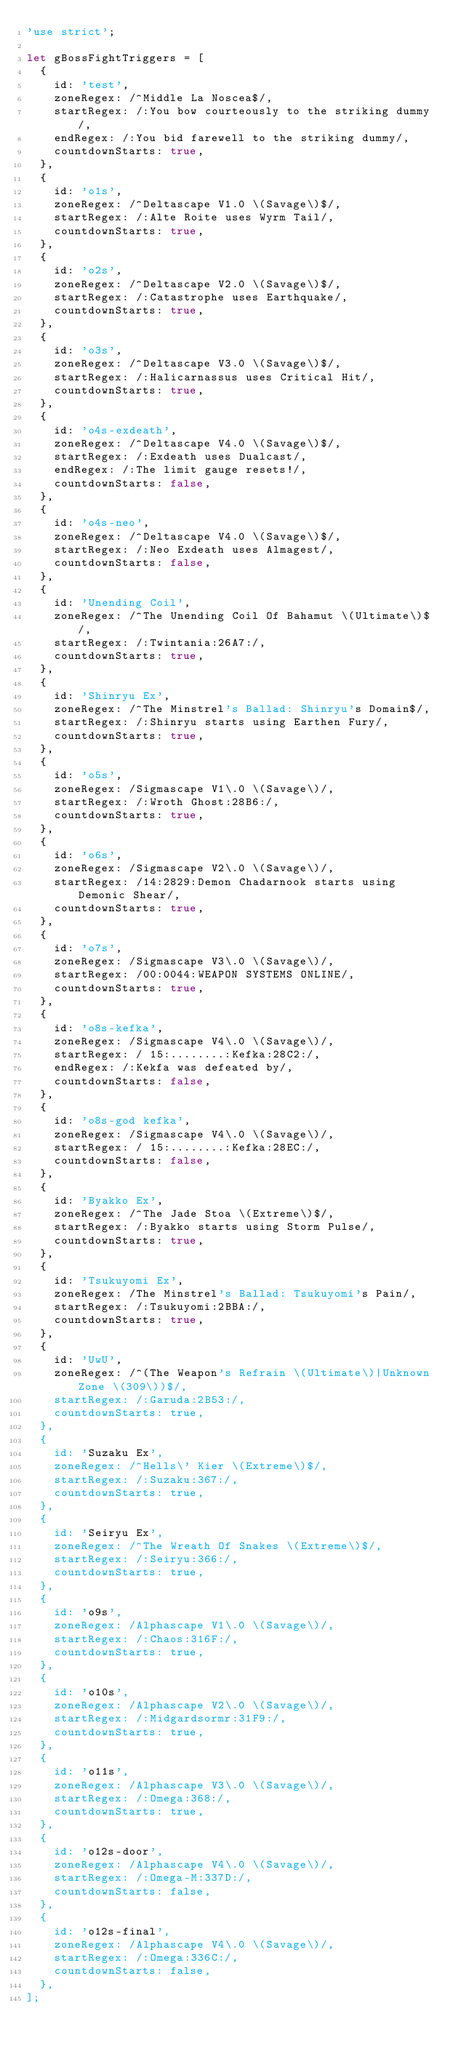<code> <loc_0><loc_0><loc_500><loc_500><_JavaScript_>'use strict';

let gBossFightTriggers = [
  {
    id: 'test',
    zoneRegex: /^Middle La Noscea$/,
    startRegex: /:You bow courteously to the striking dummy/,
    endRegex: /:You bid farewell to the striking dummy/,
    countdownStarts: true,
  },
  {
    id: 'o1s',
    zoneRegex: /^Deltascape V1.0 \(Savage\)$/,
    startRegex: /:Alte Roite uses Wyrm Tail/,
    countdownStarts: true,
  },
  {
    id: 'o2s',
    zoneRegex: /^Deltascape V2.0 \(Savage\)$/,
    startRegex: /:Catastrophe uses Earthquake/,
    countdownStarts: true,
  },
  {
    id: 'o3s',
    zoneRegex: /^Deltascape V3.0 \(Savage\)$/,
    startRegex: /:Halicarnassus uses Critical Hit/,
    countdownStarts: true,
  },
  {
    id: 'o4s-exdeath',
    zoneRegex: /^Deltascape V4.0 \(Savage\)$/,
    startRegex: /:Exdeath uses Dualcast/,
    endRegex: /:The limit gauge resets!/,
    countdownStarts: false,
  },
  {
    id: 'o4s-neo',
    zoneRegex: /^Deltascape V4.0 \(Savage\)$/,
    startRegex: /:Neo Exdeath uses Almagest/,
    countdownStarts: false,
  },
  {
    id: 'Unending Coil',
    zoneRegex: /^The Unending Coil Of Bahamut \(Ultimate\)$/,
    startRegex: /:Twintania:26A7:/,
    countdownStarts: true,
  },
  {
    id: 'Shinryu Ex',
    zoneRegex: /^The Minstrel's Ballad: Shinryu's Domain$/,
    startRegex: /:Shinryu starts using Earthen Fury/,
    countdownStarts: true,
  },
  {
    id: 'o5s',
    zoneRegex: /Sigmascape V1\.0 \(Savage\)/,
    startRegex: /:Wroth Ghost:28B6:/,
    countdownStarts: true,
  },
  {
    id: 'o6s',
    zoneRegex: /Sigmascape V2\.0 \(Savage\)/,
    startRegex: /14:2829:Demon Chadarnook starts using Demonic Shear/,
    countdownStarts: true,
  },
  {
    id: 'o7s',
    zoneRegex: /Sigmascape V3\.0 \(Savage\)/,
    startRegex: /00:0044:WEAPON SYSTEMS ONLINE/,
    countdownStarts: true,
  },
  {
    id: 'o8s-kefka',
    zoneRegex: /Sigmascape V4\.0 \(Savage\)/,
    startRegex: / 15:........:Kefka:28C2:/,
    endRegex: /:Kekfa was defeated by/,
    countdownStarts: false,
  },
  {
    id: 'o8s-god kefka',
    zoneRegex: /Sigmascape V4\.0 \(Savage\)/,
    startRegex: / 15:........:Kefka:28EC:/,
    countdownStarts: false,
  },
  {
    id: 'Byakko Ex',
    zoneRegex: /^The Jade Stoa \(Extreme\)$/,
    startRegex: /:Byakko starts using Storm Pulse/,
    countdownStarts: true,
  },
  {
    id: 'Tsukuyomi Ex',
    zoneRegex: /The Minstrel's Ballad: Tsukuyomi's Pain/,
    startRegex: /:Tsukuyomi:2BBA:/,
    countdownStarts: true,
  },
  {
    id: 'UwU',
    zoneRegex: /^(The Weapon's Refrain \(Ultimate\)|Unknown Zone \(309\))$/,
    startRegex: /:Garuda:2B53:/,
    countdownStarts: true,
  },
  {
    id: 'Suzaku Ex',
    zoneRegex: /^Hells\' Kier \(Extreme\)$/,
    startRegex: /:Suzaku:367:/,
    countdownStarts: true,
  },
  {
    id: 'Seiryu Ex',
    zoneRegex: /^The Wreath Of Snakes \(Extreme\)$/,
    startRegex: /:Seiryu:366:/,
    countdownStarts: true,
  },
  {
    id: 'o9s',
    zoneRegex: /Alphascape V1\.0 \(Savage\)/,
    startRegex: /:Chaos:316F:/,
    countdownStarts: true,
  },
  {
    id: 'o10s',
    zoneRegex: /Alphascape V2\.0 \(Savage\)/,
    startRegex: /:Midgardsormr:31F9:/,
    countdownStarts: true,
  },
  {
    id: 'o11s',
    zoneRegex: /Alphascape V3\.0 \(Savage\)/,
    startRegex: /:Omega:368:/,
    countdownStarts: true,
  },
  {
    id: 'o12s-door',
    zoneRegex: /Alphascape V4\.0 \(Savage\)/,
    startRegex: /:Omega-M:337D:/,
    countdownStarts: false,
  },
  {
    id: 'o12s-final',
    zoneRegex: /Alphascape V4\.0 \(Savage\)/,
    startRegex: /:Omega:336C:/,
    countdownStarts: false,
  },
];
</code> 